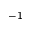Convert formula to latex. <formula><loc_0><loc_0><loc_500><loc_500>^ { - 1 }</formula> 